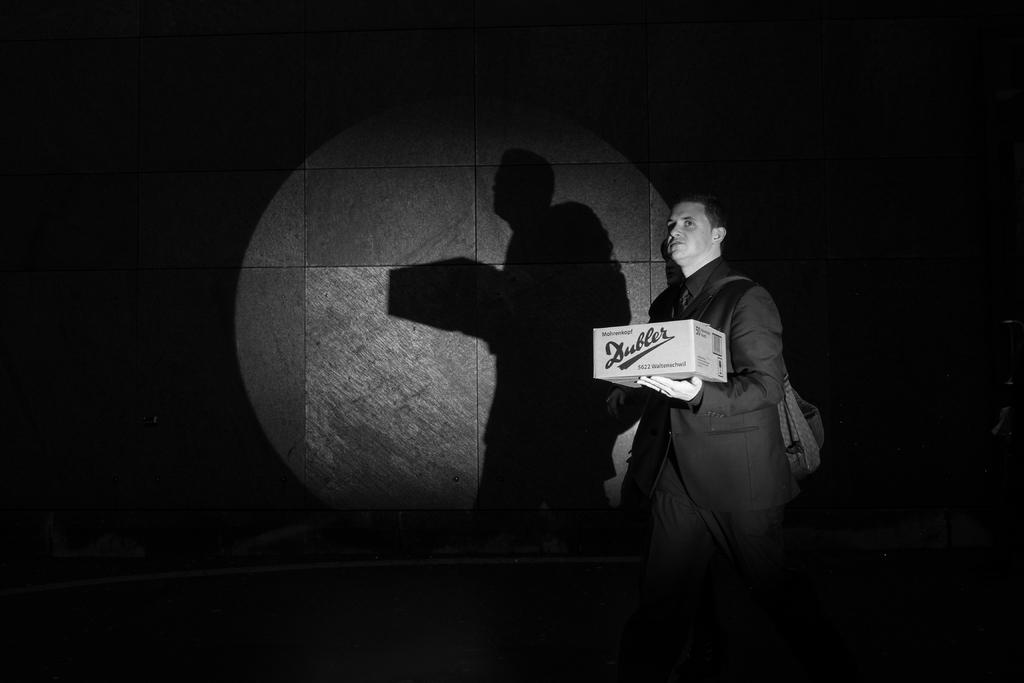Who is present in the image? There is a man in the image. What is the man holding in the image? The man is holding a box. What can be observed about the background of the image? The background of the image is dark. How many frogs are present in the image? There are no frogs present in the image. What type of team is visible in the image? There is no team present in the image. 